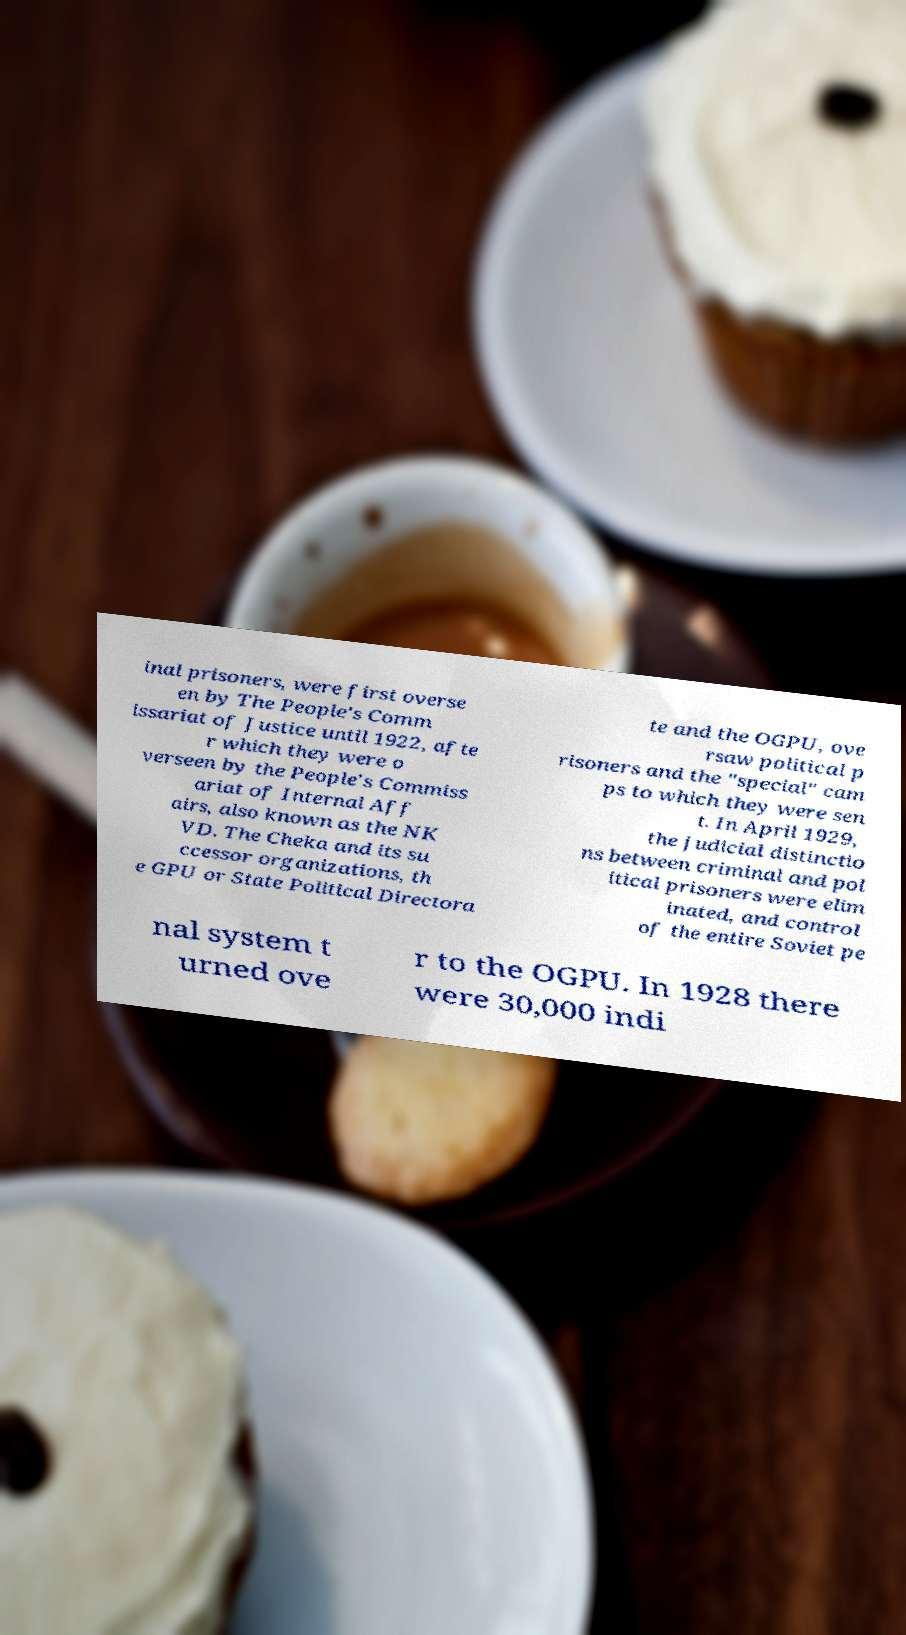Can you accurately transcribe the text from the provided image for me? inal prisoners, were first overse en by The People's Comm issariat of Justice until 1922, afte r which they were o verseen by the People's Commiss ariat of Internal Aff airs, also known as the NK VD. The Cheka and its su ccessor organizations, th e GPU or State Political Directora te and the OGPU, ove rsaw political p risoners and the "special" cam ps to which they were sen t. In April 1929, the judicial distinctio ns between criminal and pol itical prisoners were elim inated, and control of the entire Soviet pe nal system t urned ove r to the OGPU. In 1928 there were 30,000 indi 